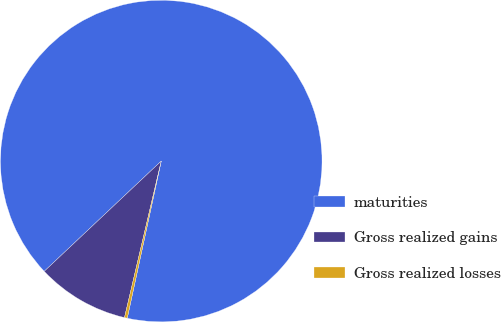Convert chart. <chart><loc_0><loc_0><loc_500><loc_500><pie_chart><fcel>maturities<fcel>Gross realized gains<fcel>Gross realized losses<nl><fcel>90.42%<fcel>9.3%<fcel>0.28%<nl></chart> 